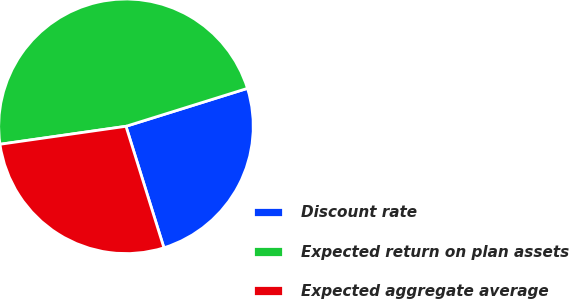Convert chart to OTSL. <chart><loc_0><loc_0><loc_500><loc_500><pie_chart><fcel>Discount rate<fcel>Expected return on plan assets<fcel>Expected aggregate average<nl><fcel>25.0%<fcel>47.44%<fcel>27.56%<nl></chart> 